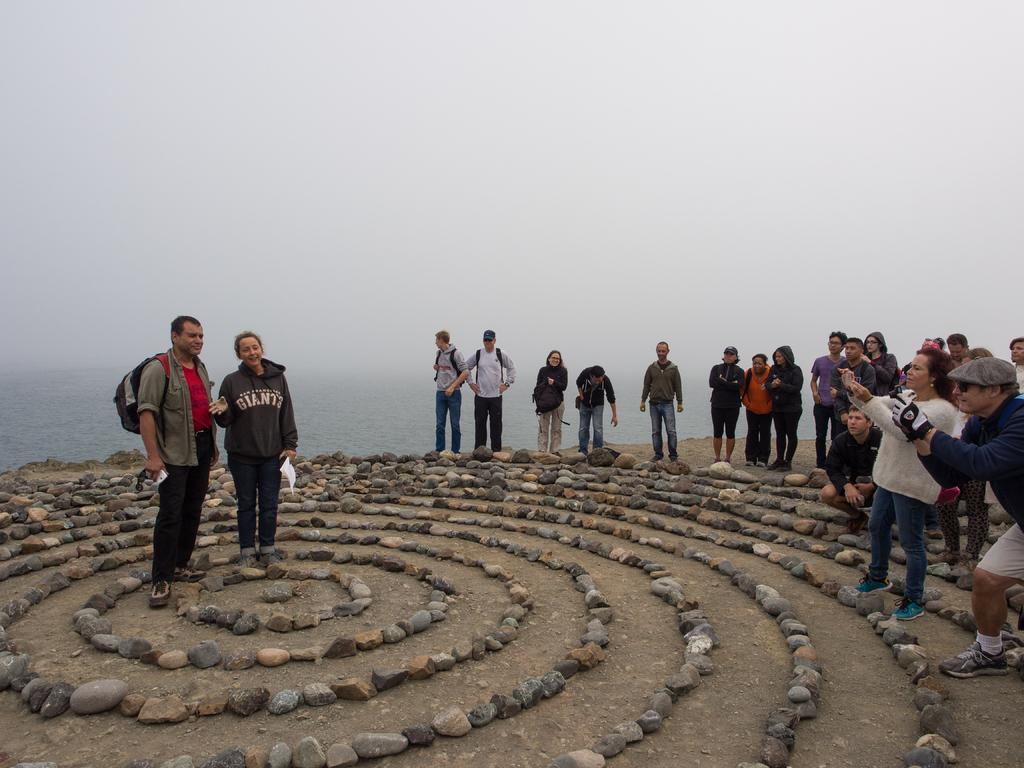Can you describe this image briefly? On the left side of the we can see persons, standing on the ground. On the right side of the image we can see many persons standing on the ground. At the bottom there are stones. In the background we can see water and sky. 